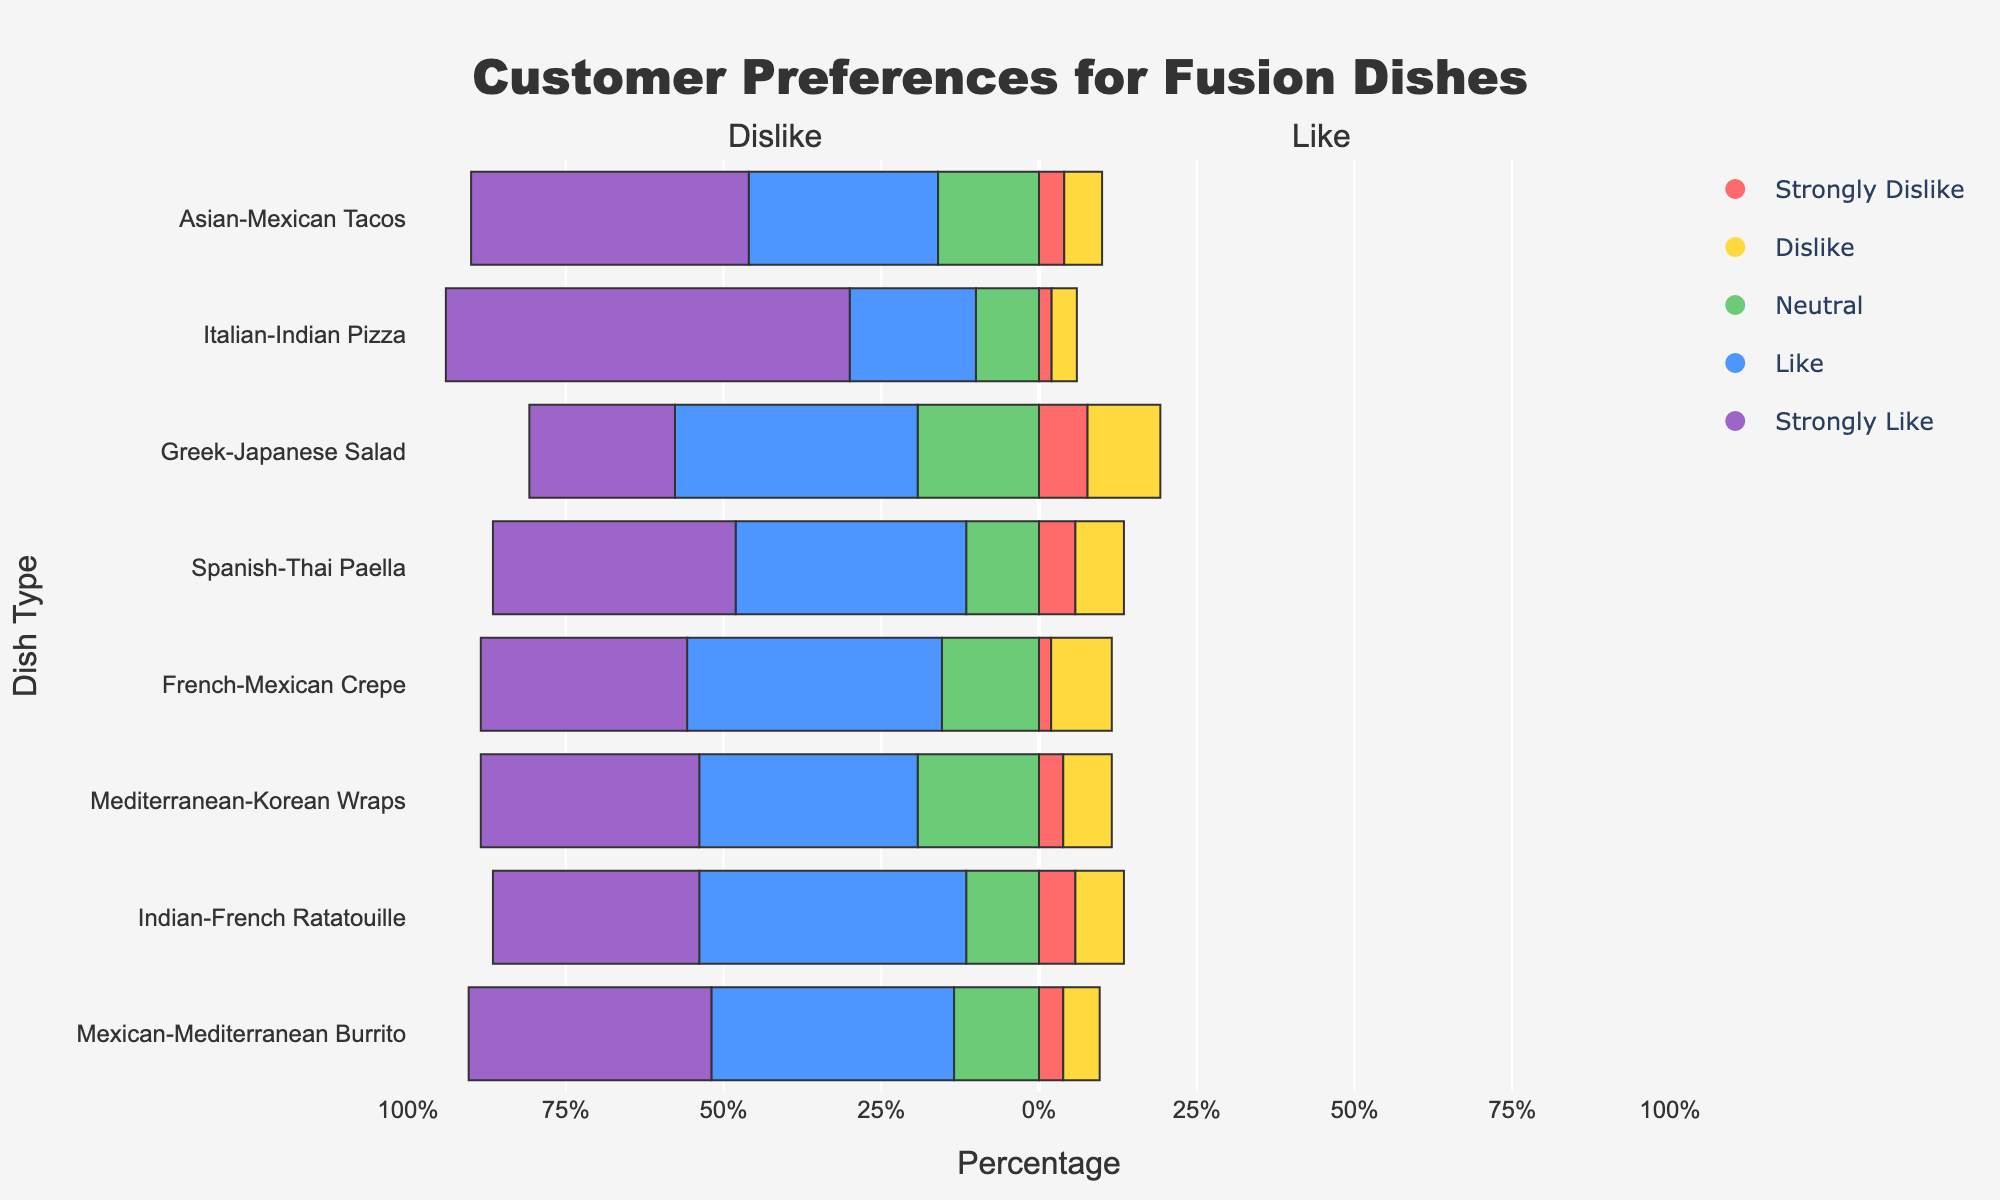What percentage of customers have a neutral opinion about the Greek-Japanese Salad with Miso-Feta Dressing? Look at the "Neutral" bar for the Greek-Japanese Salad. The hover text shows that it is 10 customers, which corresponds to \( \frac{10}{52} \times 100 \approx 19.2\% \) of total responses for this dish.
Answer: 19.2% How does the "Strongly Like" preference for Italian-Indian Pizza with Tandoori Spiced Paneer compare to that of Spanish-Thai Paella with Coconut-Lemongrass Rice? Check the "Strongly Like" bars for both dishes. The Italian-Indian Pizza has the highest bar reaching 32 customers, while the Spanish-Thai Paella has a bar reaching 20 customers. Therefore, the Italian-Indian Pizza is liked significantly more.
Answer: Italian-Indian Pizza is more liked What is the combined percentage of customers who "Like" or "Strongly Like" the Indian-French Ratatouille with Chickpea-Garam Masala? Add the percentages for "Like" and "Strongly Like" categories of the Indian-French Ratatouille. Hover text shows "Like" with 22 customers (37.3%) and "Strongly Like" with 17 customers (28.8%). Therefore, \( 37.3\% + 28.8\% = 66.1\% \).
Answer: 66.1% Which fusion dish incorporated the smallest percentage of "Dislike" responses? Look at the "Dislike" bar's length and hover text for each dish. The Italian-Indian Pizza with Tandoori Spiced Paneer has the smallest bar for "Dislike" with 2 responses, corresponding to \( \frac{2}{50} \times 100 = 4\% \).
Answer: Italian-Indian Pizza Do more customers prefer the Mediterranean-Korean Wraps with Kimchi-Hummus or the Mexican-Mediterranean Burrito with Harissa-Lime Rice? Compare the "Like" and "Strongly Like" groups for both dishes. Mediterranean-Korean Wraps: 18 (33%) + 18 (33%), totaling 66%; Mexican-Mediterranean Burrito: 20 (34.5%) + 20 (34.5%), totaling 69%. More customers prefer the burrito as 69% > 66%.
Answer: Mexican-Mediterranean Burrito Which fusion dish combination has the highest percentage of "Strongly Dislike" responses? Look at the "Strongly Dislike" bar for each dish. The Greek-Japanese Salad with Miso-Feta Dressing has the highest bar with 4 responses, which is \( \frac{4}{52} \times 100 \approx 7.7\% \).
Answer: Greek-Japanese Salad When comparing just "Like" preferences, which dish is more popular: French-Mexican Crepe with Chipotle-Saffron Cream or Asian-Mexican Tacos with Sesame-Tamari Marinated Tofu? Look at the "Like" bars. The French-Mexican Crepe has 21 customers, whereas the Asian-Mexican Tacos have 15 customers. The Crepe is therefore more popular in the "Like" category.
Answer: French-Mexican Crepe What proportion of customers are neutral towards the Mediterranean-Korean Wraps with Kimchi-Hummus? Look at the "Neutral" bar for the dish and the hover text shows it is 10 customers. The sum of responses for this dish is 52, so \( \frac{10}{52} \times 100 \approx 19.2\% \).
Answer: 19.2% 